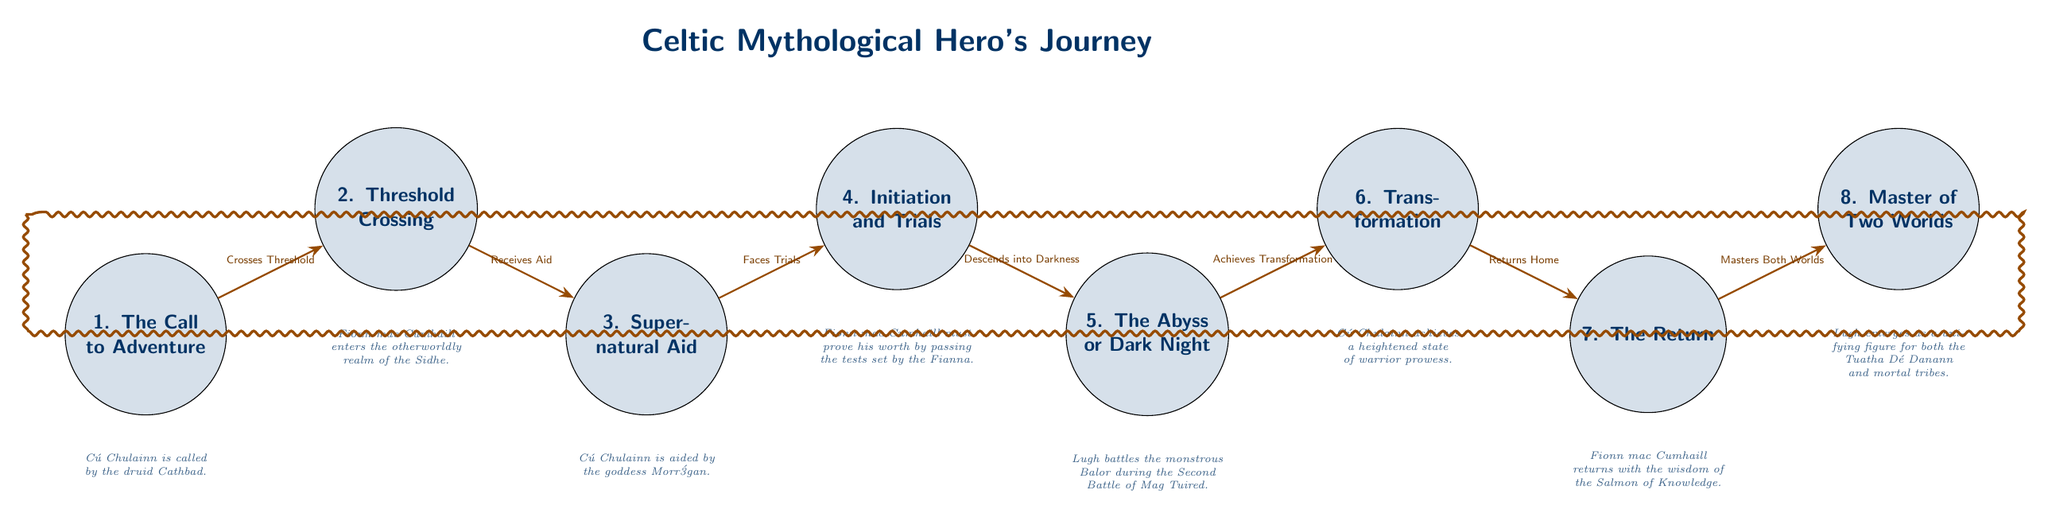What is the first stage of the hero's journey? The diagram lists "1. The Call to Adventure" as the first stage, indicating that this is where the hero is summoned or inspired to begin their adventure.
Answer: The Call to Adventure How many stages are included in the diagram? There are a total of eight nodes in the diagram representing different stages of the hero's journey, including each unique aspect of the journey.
Answer: Eight Which hero's journey stage is associated with the supernatural aid? The diagram identifies "3. Supernatural Aid" as the specific stage where the hero receives assistance from otherworldly forces or beings, crucial in aiding their quest.
Answer: Supernatural Aid What is the relationship between the second and third stages? The diagram illustrates that the second stage, "Threshold Crossing," leads to the third stage, "Supernatural Aid," indicating that crossing this threshold allows the hero to receive help.
Answer: Receives Aid Which hero is linked to the encounter with the goddess Morrígan? The diagram specifically states that "Cú Chulainn is aided by the goddess Morrígan" in the context of the supernatural assistance the hero receives.
Answer: Cú Chulainn What does the hero achieve during the sixth stage? The sixth stage, "Transformation," signifies the moment when the hero undergoes significant personal growth or change, often becoming a better version of themselves.
Answer: Achieves Transformation Which stage signifies the hero mastering both worlds? The final stage, "8. Master of Two Worlds," indicates the culmination of the hero's journey where they gain mastery over both the ordinary and extraordinary realms they inhabit.
Answer: Master of Two Worlds What is the key trial faced in the fourth stage? The diagram states that "Fionn mac Cumhaill must prove his worth by passing the tests set by the Fianna" during the initiation and trials stage, emphasizing the challenges of this phase.
Answer: Passing the tests 